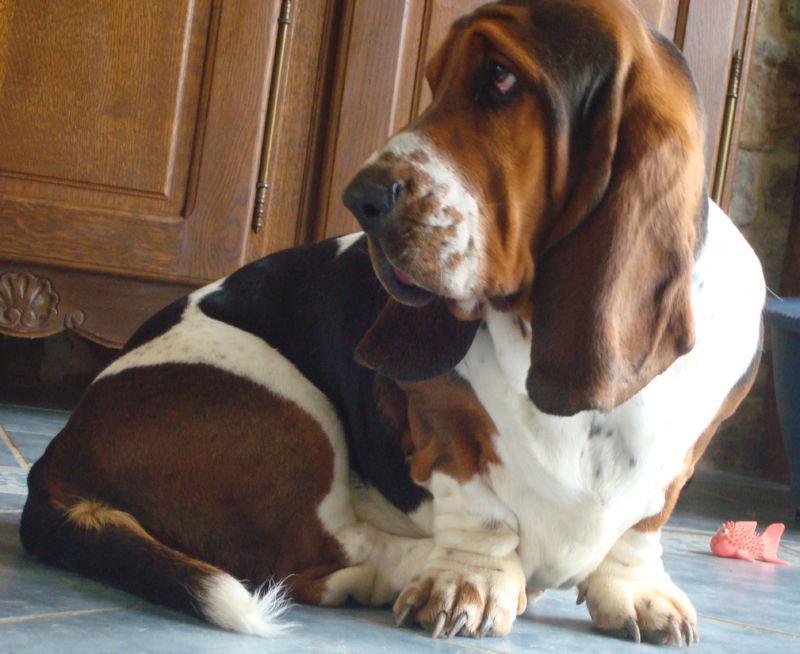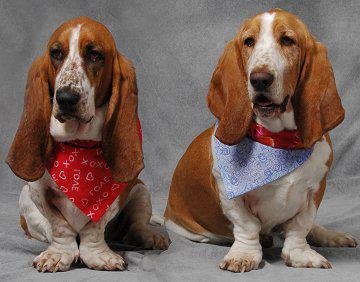The first image is the image on the left, the second image is the image on the right. Assess this claim about the two images: "One image has no less than two dogs in it.". Correct or not? Answer yes or no. Yes. The first image is the image on the left, the second image is the image on the right. For the images shown, is this caption "One of the basset hounds is sitting in the grass." true? Answer yes or no. No. 